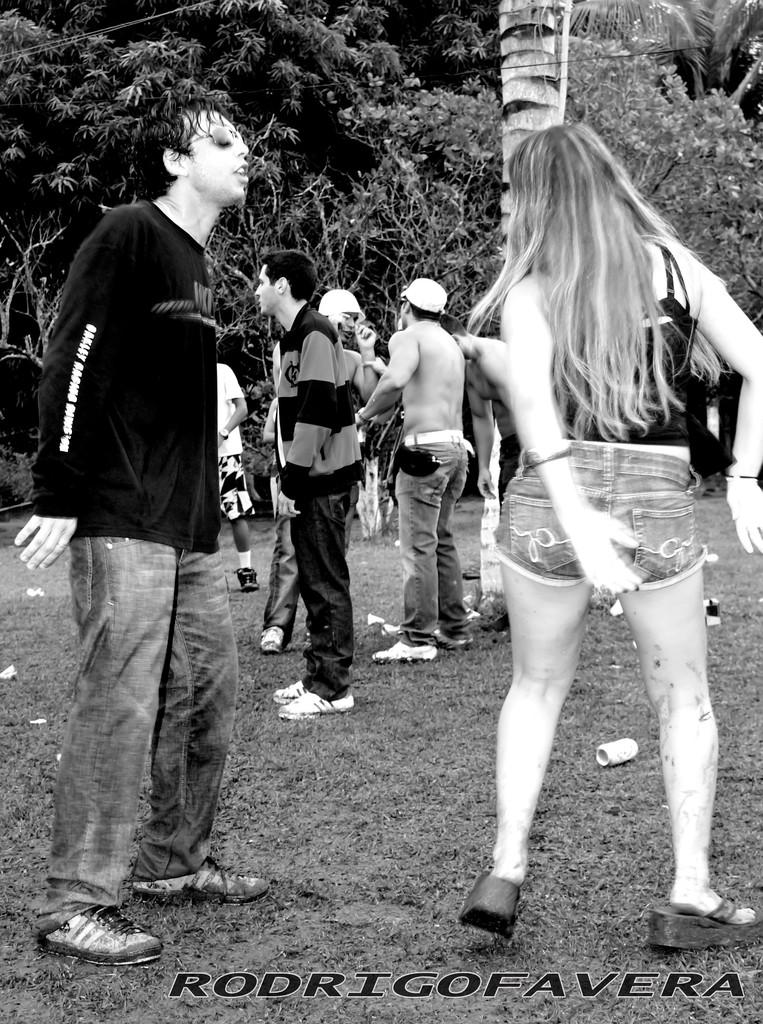Who or what is present in the image? There are people in the image. What object can be seen on the ground? There is a soda can on the ground. What type of natural elements are visible in the image? There are trees in the image. What else can be seen in the image besides people and trees? There is text visible in the image. How is the image presented in terms of color? The image is in black and white mode. How does the hole in the ground affect the transport of the people in the image? There is no hole in the ground mentioned in the image, so it cannot affect the transport of the people. 